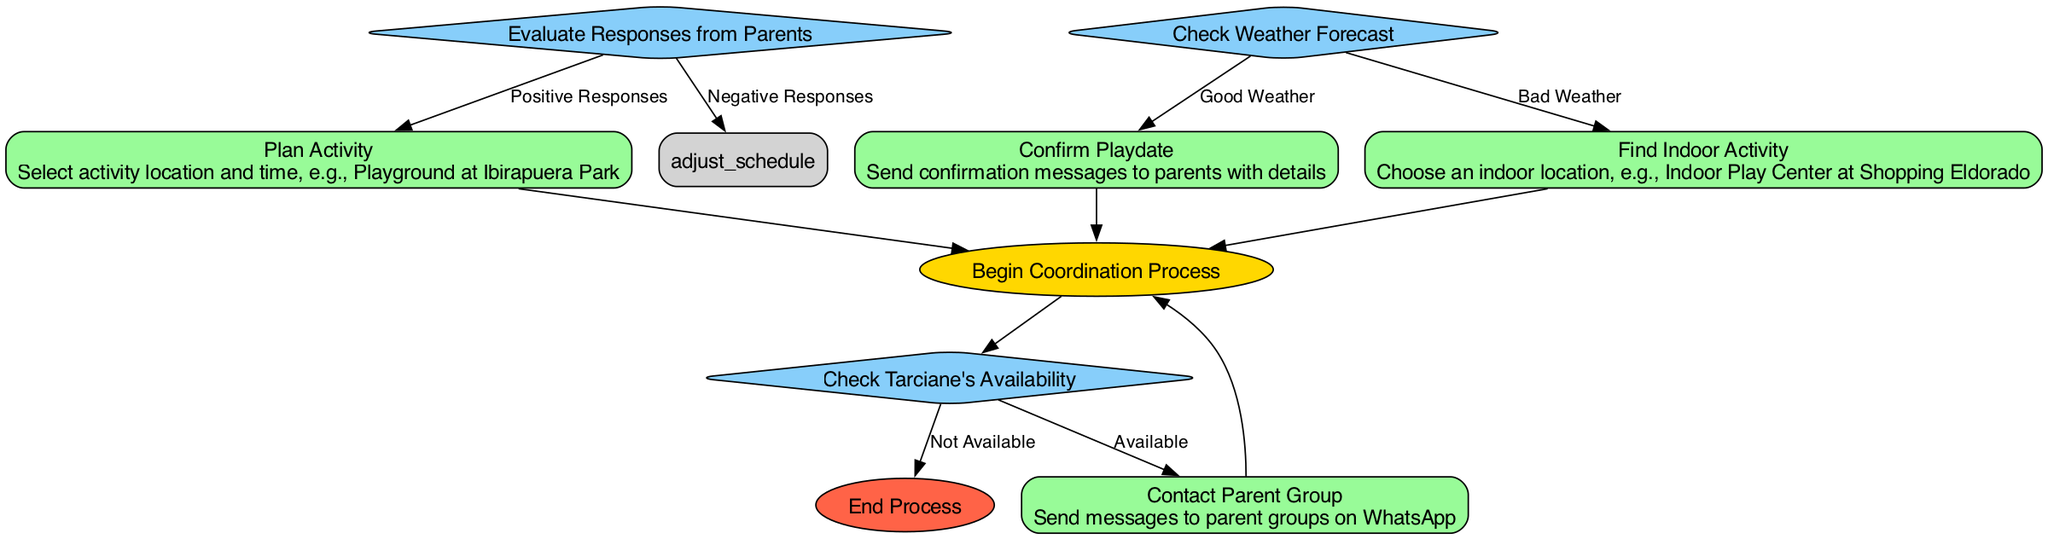What is the first step in coordinating activities for Tarciane? The diagram indicates the first step is labeled "Begin Coordination Process," which serves as the starting point for the entire process.
Answer: Begin Coordination Process How many decisions are present in the diagram? The flowchart includes three decision nodes: "Check Tarciane's Availability," "Evaluate Responses from Parents," and "Check Weather Forecast," summing up to three.
Answer: 3 What happens if Tarciane is not available? If Tarciane is not available, the flowchart leads directly to the "End Process," indicating that no further action will be taken.
Answer: End Process What activity location is proposed for outdoor playdates? The diagram specifies "Playground at Ibirapuera Park" as the proposed outdoor location for the playdate activity planning.
Answer: Playground at Ibirapuera Park What action follows after receiving positive responses from parents? The successful outcome of receiving positive responses leads to the "Plan Activity" action, which directs the next steps in organizing the playdate.
Answer: Plan Activity What do you do if the weather is bad? In the event of bad weather, the flowchart directs you to "Find Indoor Activity," suggesting an alternative for the planned activity.
Answer: Find Indoor Activity What is the last step in the coordination process? The diagram shows "End Process" as the final step, indicating the conclusion of the coordination activities once completed.
Answer: End Process What is the action taken to communicate with other parents? The diagram specifies that the action taken is to "Contact Parent Group," which involves sending messages to inform about the planned activities.
Answer: Contact Parent Group What happens after the "Plan Activity" action? Following the "Plan Activity" action, the next decision node is "Check Weather Forecast," making it necessary to assess the weather conditions before moving forward.
Answer: Check Weather Forecast 